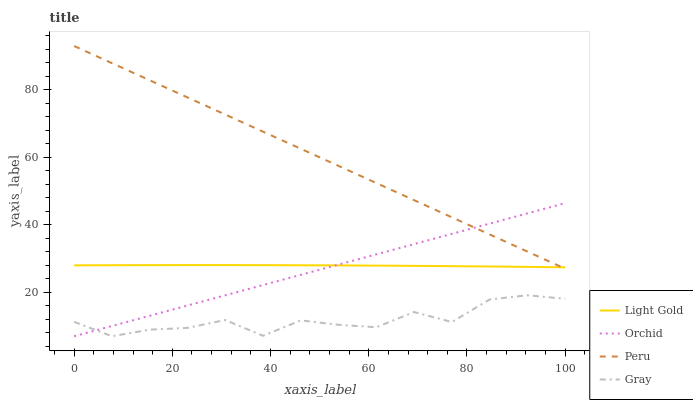Does Gray have the minimum area under the curve?
Answer yes or no. Yes. Does Peru have the maximum area under the curve?
Answer yes or no. Yes. Does Light Gold have the minimum area under the curve?
Answer yes or no. No. Does Light Gold have the maximum area under the curve?
Answer yes or no. No. Is Orchid the smoothest?
Answer yes or no. Yes. Is Gray the roughest?
Answer yes or no. Yes. Is Light Gold the smoothest?
Answer yes or no. No. Is Light Gold the roughest?
Answer yes or no. No. Does Peru have the lowest value?
Answer yes or no. No. Does Peru have the highest value?
Answer yes or no. Yes. Does Light Gold have the highest value?
Answer yes or no. No. Is Gray less than Light Gold?
Answer yes or no. Yes. Is Light Gold greater than Gray?
Answer yes or no. Yes. Does Orchid intersect Gray?
Answer yes or no. Yes. Is Orchid less than Gray?
Answer yes or no. No. Is Orchid greater than Gray?
Answer yes or no. No. Does Gray intersect Light Gold?
Answer yes or no. No. 